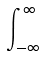Convert formula to latex. <formula><loc_0><loc_0><loc_500><loc_500>\int _ { - \infty } ^ { \infty }</formula> 